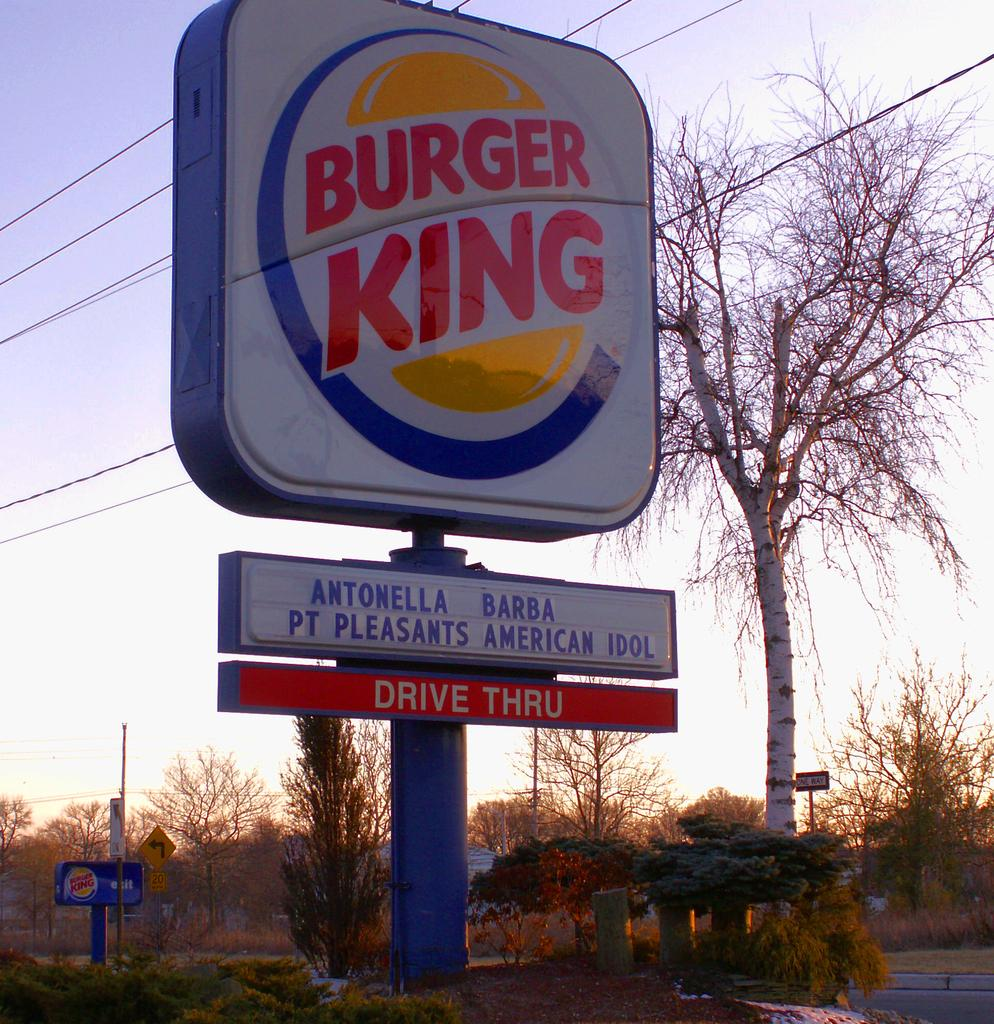Provide a one-sentence caption for the provided image. Burger King gives a shout out to Antonella Barba, Pt. Pleasant's American Idol. 